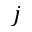<formula> <loc_0><loc_0><loc_500><loc_500>j</formula> 